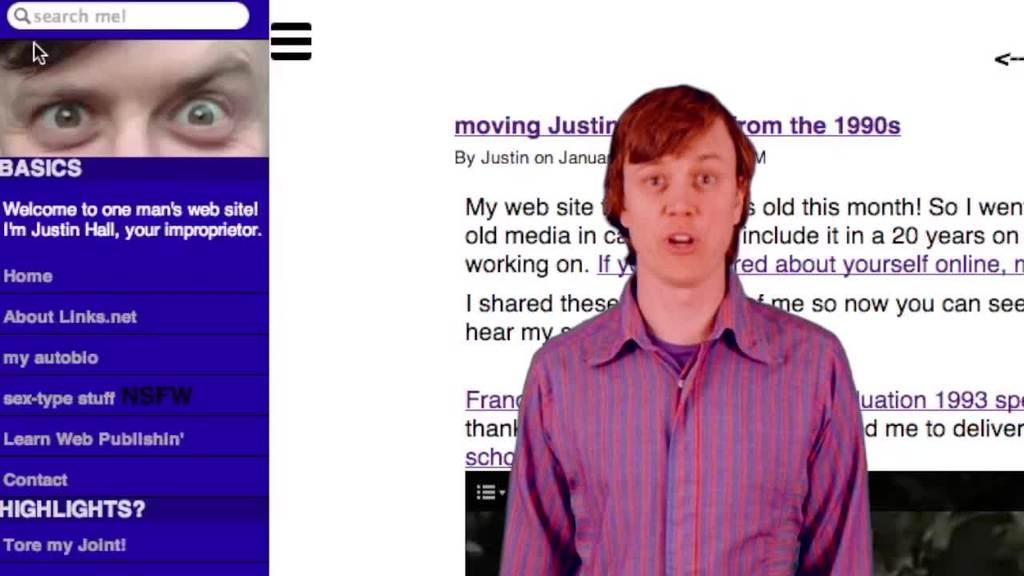What is the main subject of the image? The main subject of the image is a web page. Can you describe the person in the image? There is a person in the front of the image. What else can be seen in the background of the image? There is text in the background of the image. What part of the person's interaction with the web page is visible? A person's eyes and cursor are visible on the left side of the image. What type of marble is being used to decorate the actor's dressing room in the image? There is no actor or marble present in the image; it features a web page and a person interacting with it. 